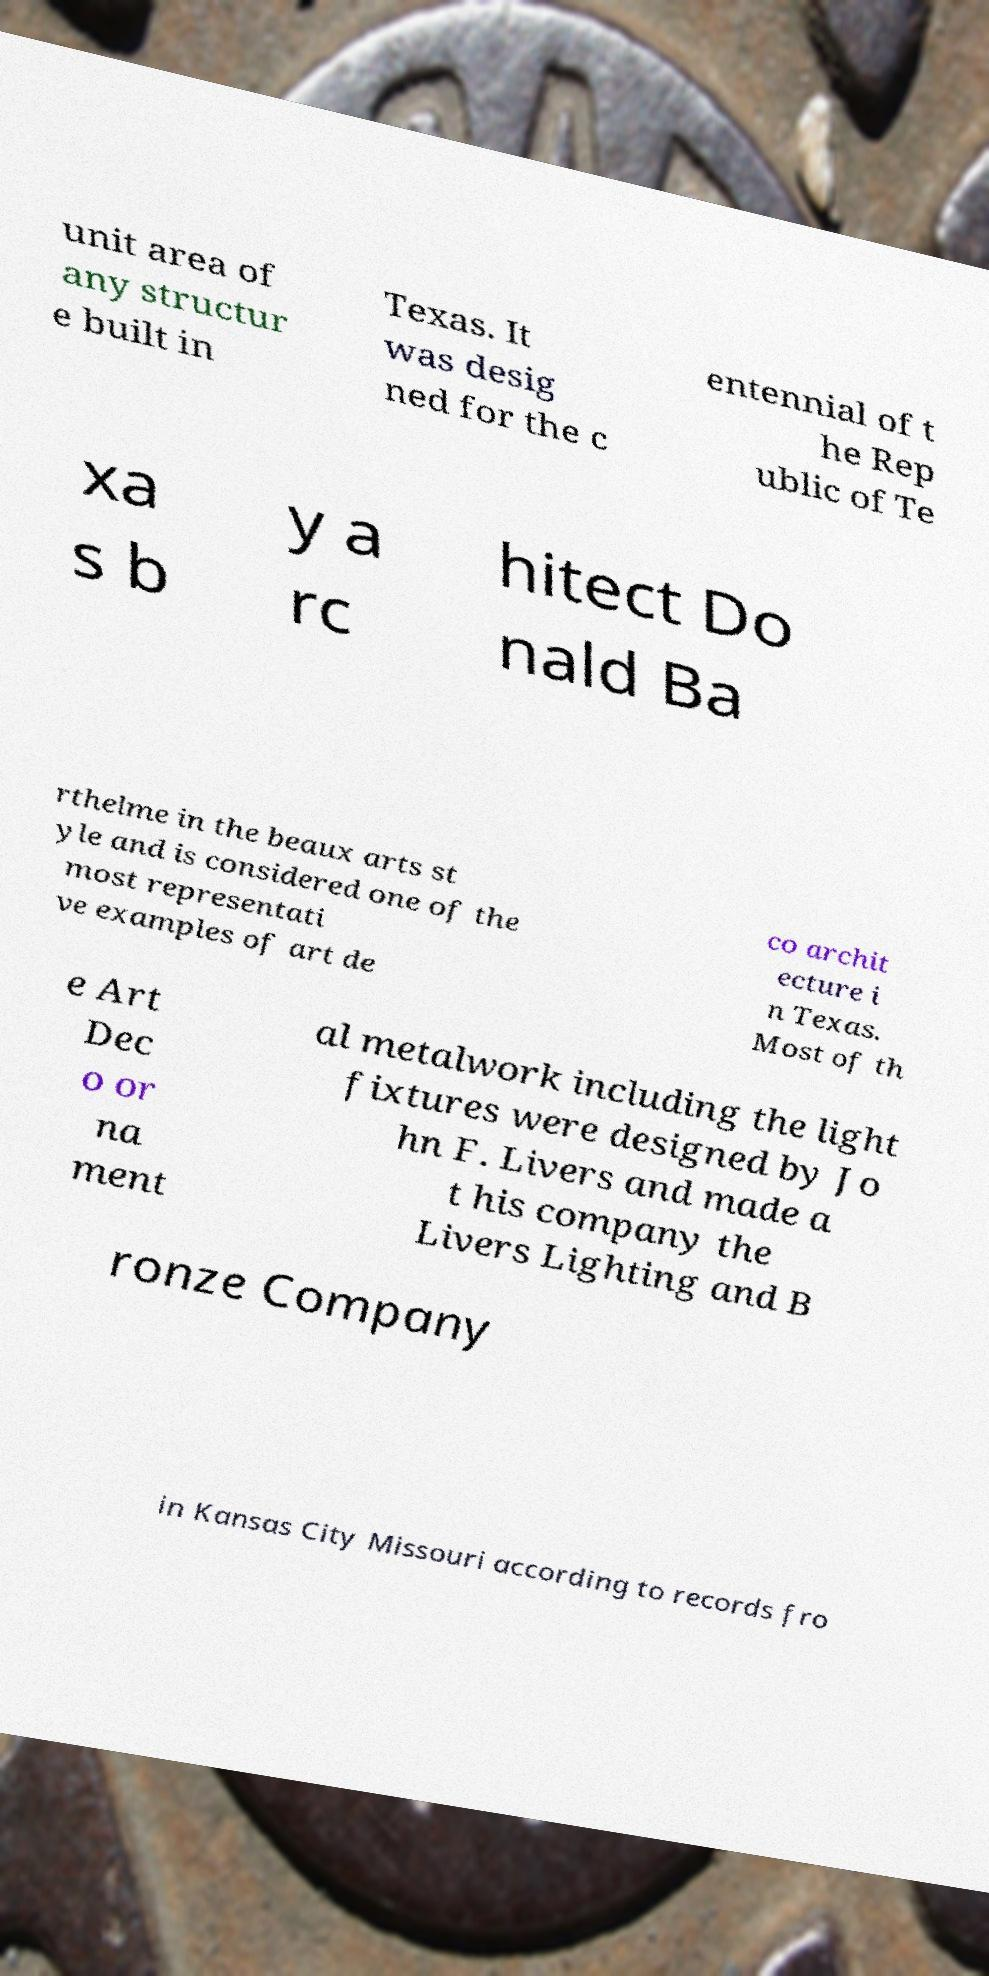Please read and relay the text visible in this image. What does it say? unit area of any structur e built in Texas. It was desig ned for the c entennial of t he Rep ublic of Te xa s b y a rc hitect Do nald Ba rthelme in the beaux arts st yle and is considered one of the most representati ve examples of art de co archit ecture i n Texas. Most of th e Art Dec o or na ment al metalwork including the light fixtures were designed by Jo hn F. Livers and made a t his company the Livers Lighting and B ronze Company in Kansas City Missouri according to records fro 